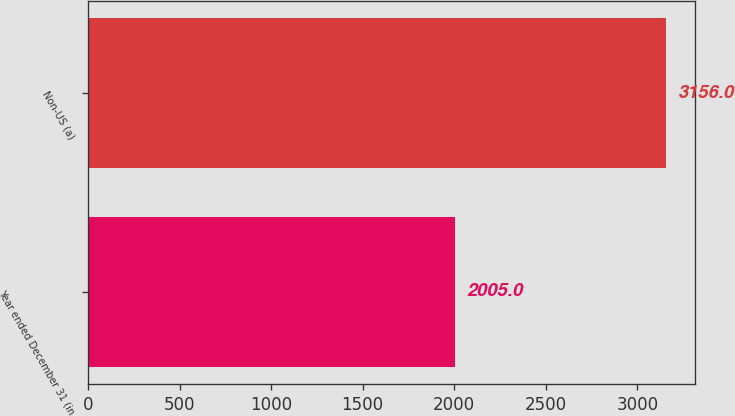Convert chart. <chart><loc_0><loc_0><loc_500><loc_500><bar_chart><fcel>Year ended December 31 (in<fcel>Non-US (a)<nl><fcel>2005<fcel>3156<nl></chart> 